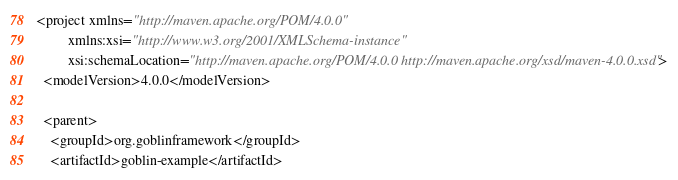<code> <loc_0><loc_0><loc_500><loc_500><_XML_><project xmlns="http://maven.apache.org/POM/4.0.0"
         xmlns:xsi="http://www.w3.org/2001/XMLSchema-instance"
         xsi:schemaLocation="http://maven.apache.org/POM/4.0.0 http://maven.apache.org/xsd/maven-4.0.0.xsd">
  <modelVersion>4.0.0</modelVersion>

  <parent>
    <groupId>org.goblinframework</groupId>
    <artifactId>goblin-example</artifactId></code> 